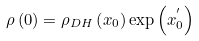<formula> <loc_0><loc_0><loc_500><loc_500>\rho \left ( 0 \right ) = \rho _ { D H } \left ( x _ { 0 } \right ) \exp \left ( x _ { 0 } ^ { ^ { \prime } } \right )</formula> 